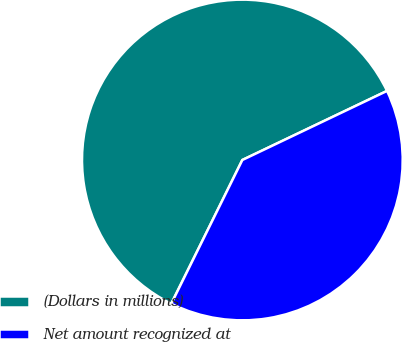Convert chart. <chart><loc_0><loc_0><loc_500><loc_500><pie_chart><fcel>(Dollars in millions)<fcel>Net amount recognized at<nl><fcel>60.6%<fcel>39.4%<nl></chart> 